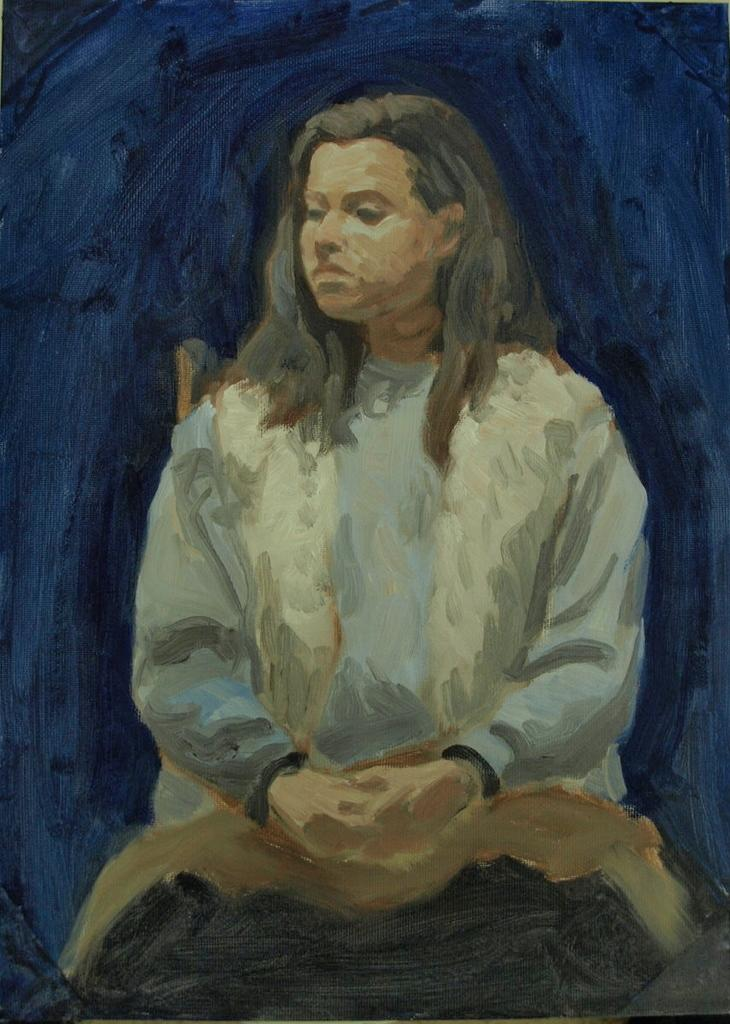What is depicted in the image? There is a painting of a person in the image. Can you describe the person's attire in the painting? The person in the painting is wearing a blue and white color dress. What color is the background of the painting? The background of the painting is blue. How many chairs are visible in the painting? There are no chairs visible in the painting; it is a painting of a person with a blue and white color dress and a blue background. 